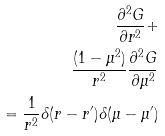Convert formula to latex. <formula><loc_0><loc_0><loc_500><loc_500>\frac { \partial ^ { 2 } G } { \partial r ^ { 2 } } + \\ \frac { ( 1 - \mu ^ { 2 } ) } { r ^ { 2 } } \frac { \partial ^ { 2 } G } { \partial \mu ^ { 2 } } \\ = \frac { 1 } { r ^ { 2 } } \delta ( r - r ^ { \prime } ) \delta ( \mu - \mu ^ { \prime } )</formula> 